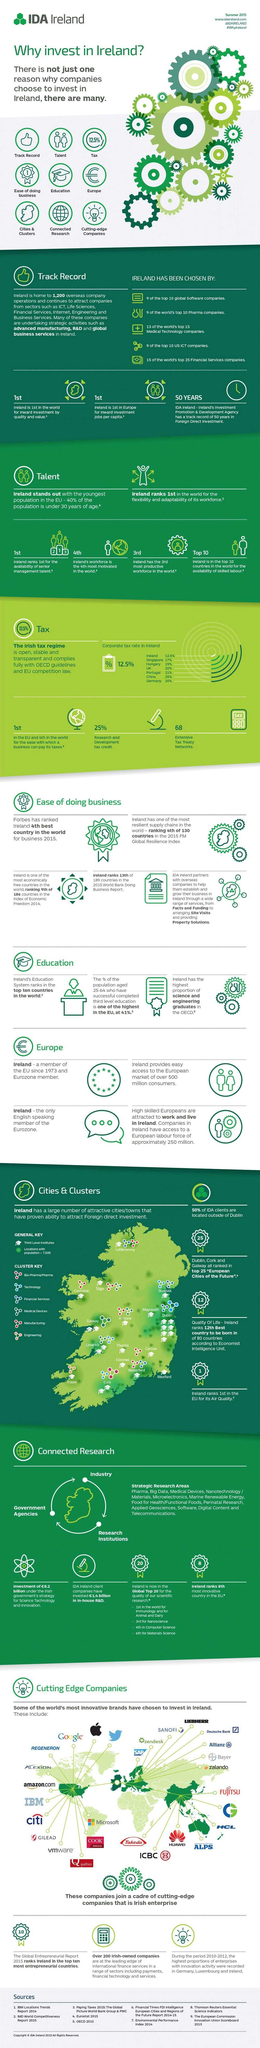What is the corporate tax rate in UK in 2015?
Answer the question with a short phrase. 20% What percentage of the population aged 25-64 years in Ireland have completed third level education in 2015? 41% What percentage is the research & development tax credit in Ireland in 2015? 25% How many extensive tax treaty networks were established in Ireland in 2015? 68 